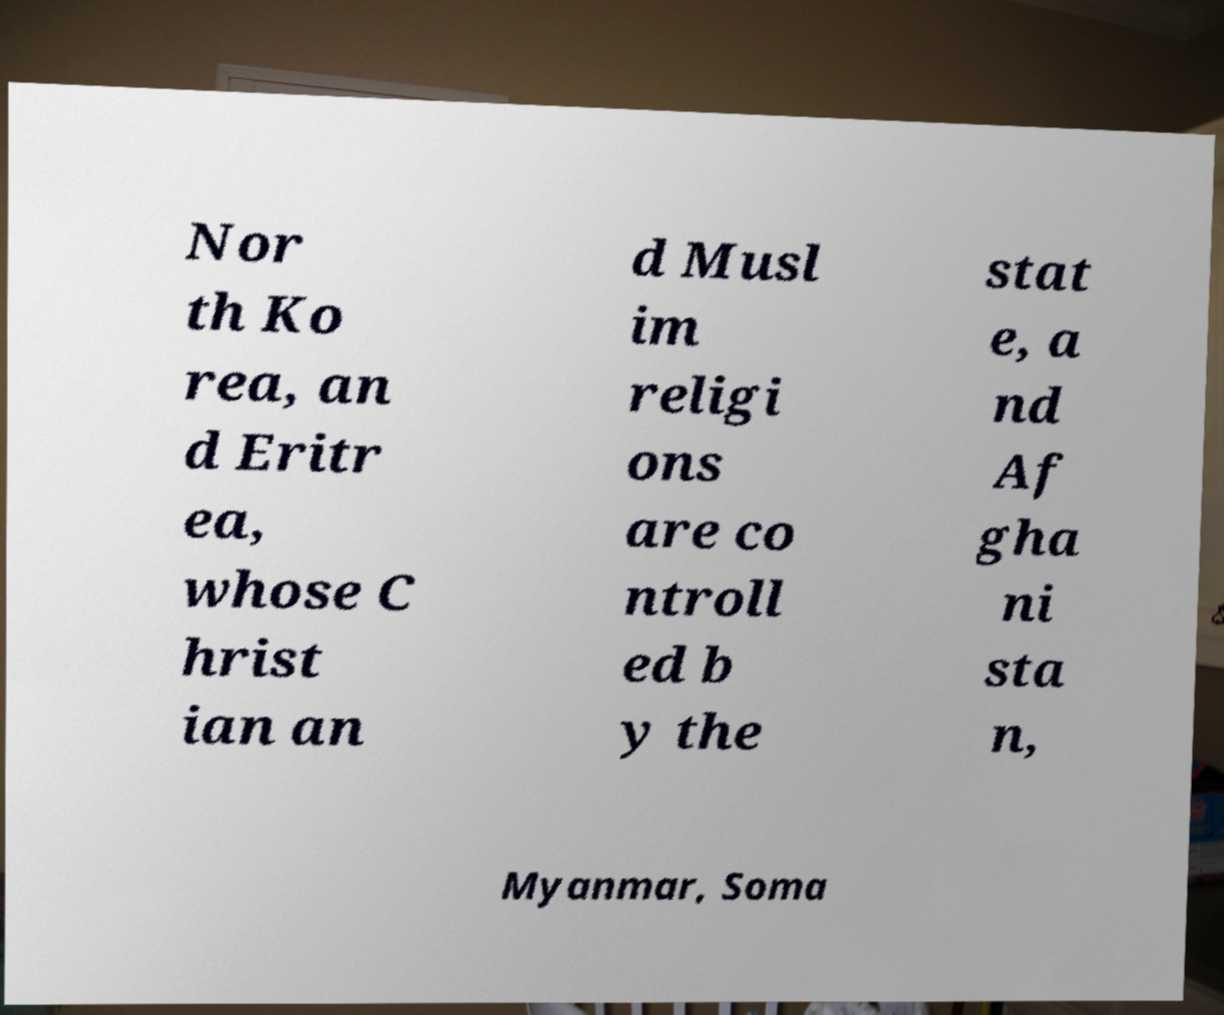There's text embedded in this image that I need extracted. Can you transcribe it verbatim? Nor th Ko rea, an d Eritr ea, whose C hrist ian an d Musl im religi ons are co ntroll ed b y the stat e, a nd Af gha ni sta n, Myanmar, Soma 